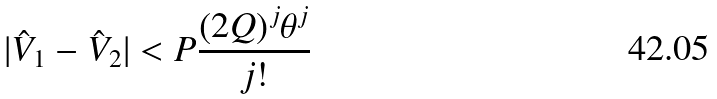Convert formula to latex. <formula><loc_0><loc_0><loc_500><loc_500>| \hat { V } _ { 1 } - \hat { V } _ { 2 } | < P \frac { ( 2 Q ) ^ { j } \theta ^ { j } } { j ! }</formula> 